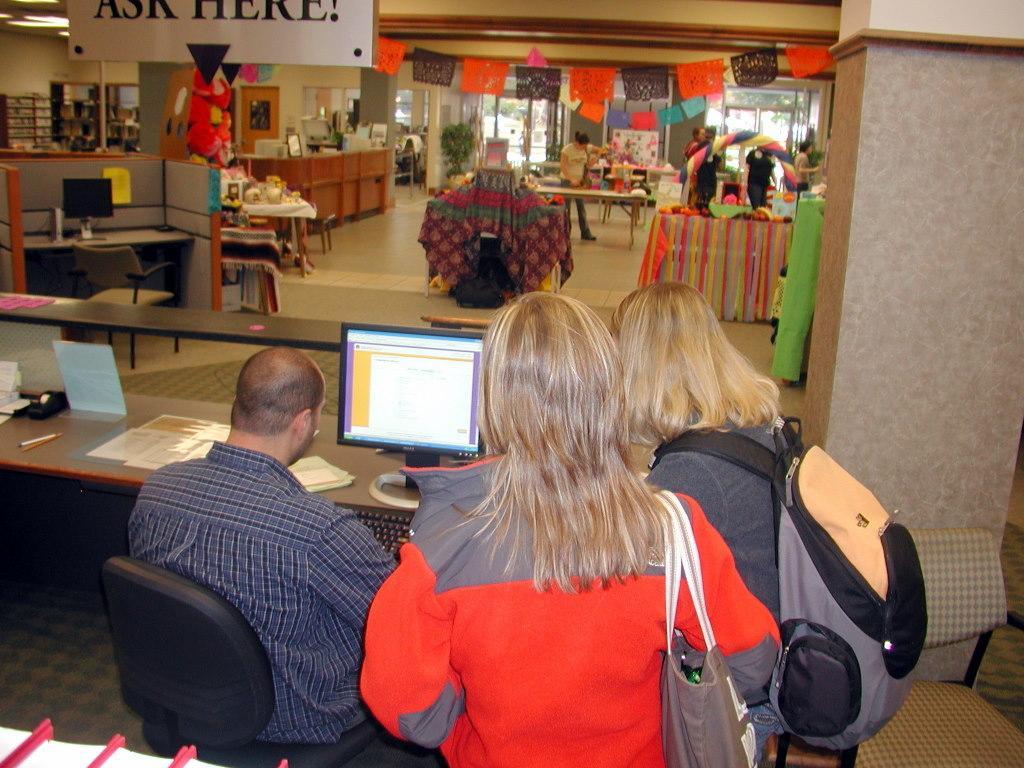Could you give a brief overview of what you see in this image? In the image we can see there are people standing on the ground and there is a man sitting on the chair. There is a monitor and keyboard kept on the table. Behind there are tables and racks kept on the ground. 